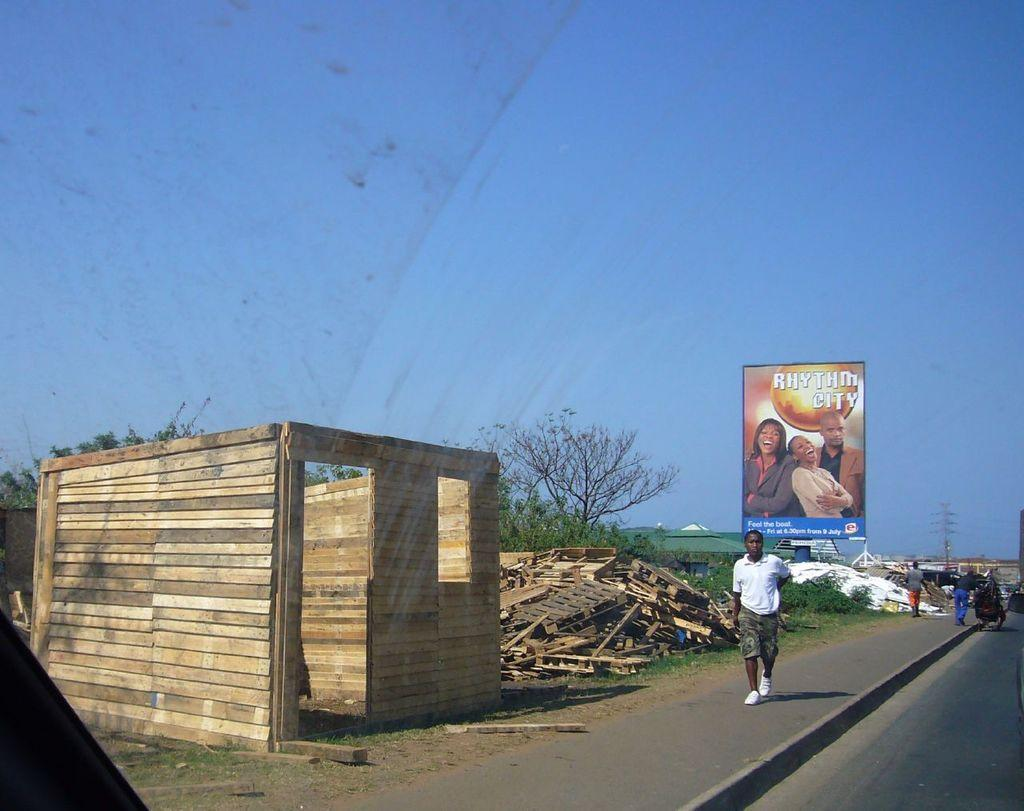Provide a one-sentence caption for the provided image. A man is walking down the road with a partially completed shed off to the side of the road and the cover of Rhythm City floating in the sky. 